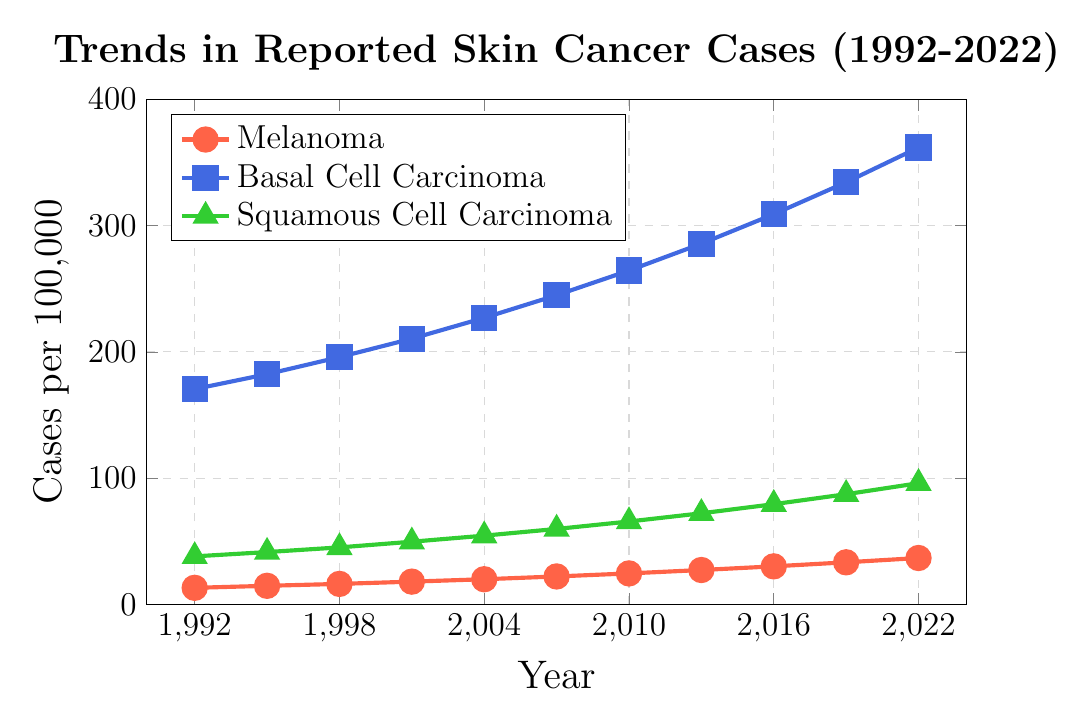What's the range of values for Basal Cell Carcinoma? The range of values for Basal Cell Carcinoma can be found by subtracting the minimum value from the maximum value. The minimum value is 170.5 (in 1992), and the maximum value is 361.7 (in 2022). So the range is 361.7 - 170.5 = 191.2
Answer: 191.2 Which type of skin cancer showed the highest increase in cases over the 30 years? To determine which type of skin cancer showed the highest increase, we subtract the initial value in 1992 from the final value in 2022 for each type. Melanoma increased from 13.2 to 36.8, an increase of 23.6. Basal Cell Carcinoma increased from 170.5 to 361.7, an increase of 191.2. Squamous Cell Carcinoma increased from 38.1 to 96.0, an increase of 57.9. Basal Cell Carcinoma had the highest increase.
Answer: Basal Cell Carcinoma In which period did Squamous Cell Carcinoma increase the most rapidly? Examining the increments, we need to find the period with the highest increase for Squamous Cell Carcinoma. The increases are 1992-1995: 3.4, 1995-1998: 3.7, 1998-2001: 4.5, 2001-2004: 4.8, 2004-2007: 5.3, 2007-2010: 5.9, 2010-2013: 6.5, 2013-2016: 7.2, 2016-2019: 7.9, 2019-2022: 8.7. The period 2019-2022 had the highest increase.
Answer: 2019-2022 What is the cumulative increase in Melanoma cases from 1992 to 2022? To find the cumulative increase, subtract the initial value in 1992 from the final value in 2022. Melanoma increased from 13.2 to 36.8. The cumulative increase is 36.8 - 13.2 = 23.6
Answer: 23.6 How does the growth trend of Basal Cell Carcinoma compare visually to Melanoma? Visually, the Basal Cell Carcinoma line on the plot is consistently higher than the Melanoma line and shows a steeper slope, indicating a faster growth rate and larger increase in cases over the period.
Answer: Basal grows faster than Melanoma How much more prevalent was Basal Cell Carcinoma compared to Squamous Cell Carcinoma in 2022? Subtract the cases of Squamous Cell Carcinoma in 2022 from the cases of Basal Cell Carcinoma in 2022. Basal Cell Carcinoma was 361.7, and Squamous Cell Carcinoma was 96.0. The difference is 361.7 - 96.0 = 265.7
Answer: 265.7 What's the average annual increase in cases for Squamous Cell Carcinoma over the period? To find the average annual increase, subtract the initial value in 1992 from the final value in 2022, then divide by the number of years (2022 - 1992 = 30 years). The increase is 96.0 - 38.1 = 57.9. The average annual increase is 57.9 / 30 = 1.93
Answer: 1.93 What is the visual difference between the trend lines of Melanoma and Squamous Cell Carcinoma? Visually, the trend line for Melanoma is represented by a steady upward trend with small markers, whereas the trend line for Squamous Cell Carcinoma also rises steadily but more gradually compared to Melanoma.
Answer: Melanoma line rises faster 